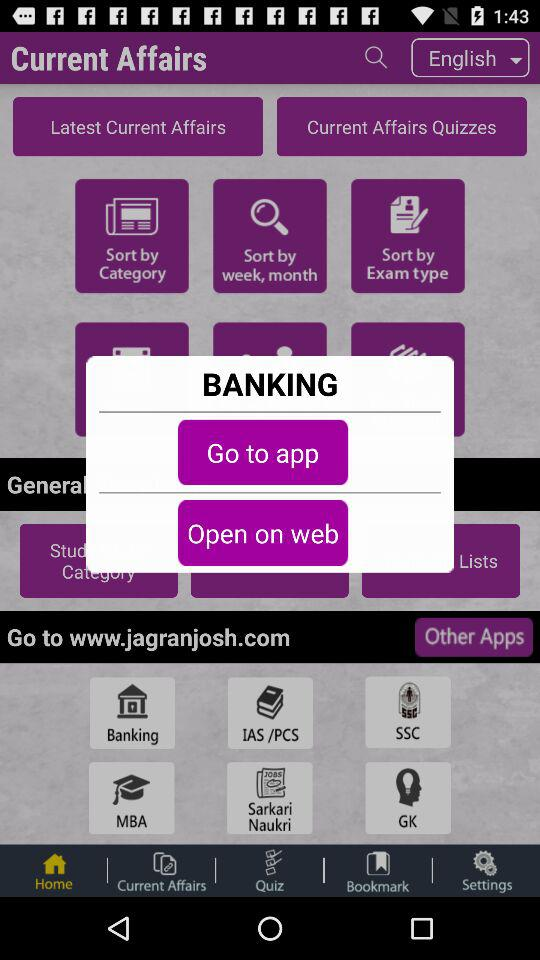What is the selected language? The selected language is English. 